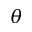<formula> <loc_0><loc_0><loc_500><loc_500>\theta</formula> 